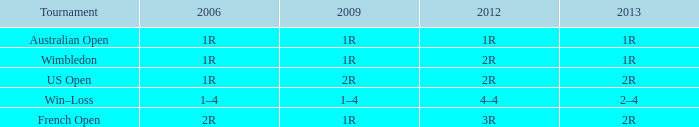What shows for 2013 when the 2012 is 2r, and a 2009 is 2r? 2R. 